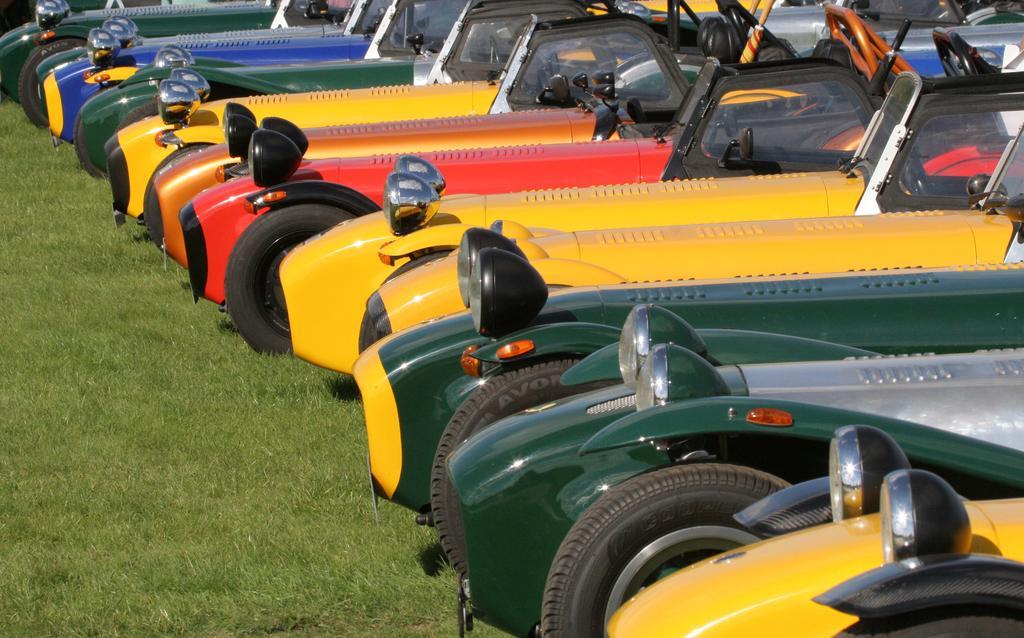Please provide a concise description of this image. This picture is clicked outside. On the right we can see there are many number of vehicles which are of different colors and seems to be parked on the ground. The ground is covered with the green grass. 